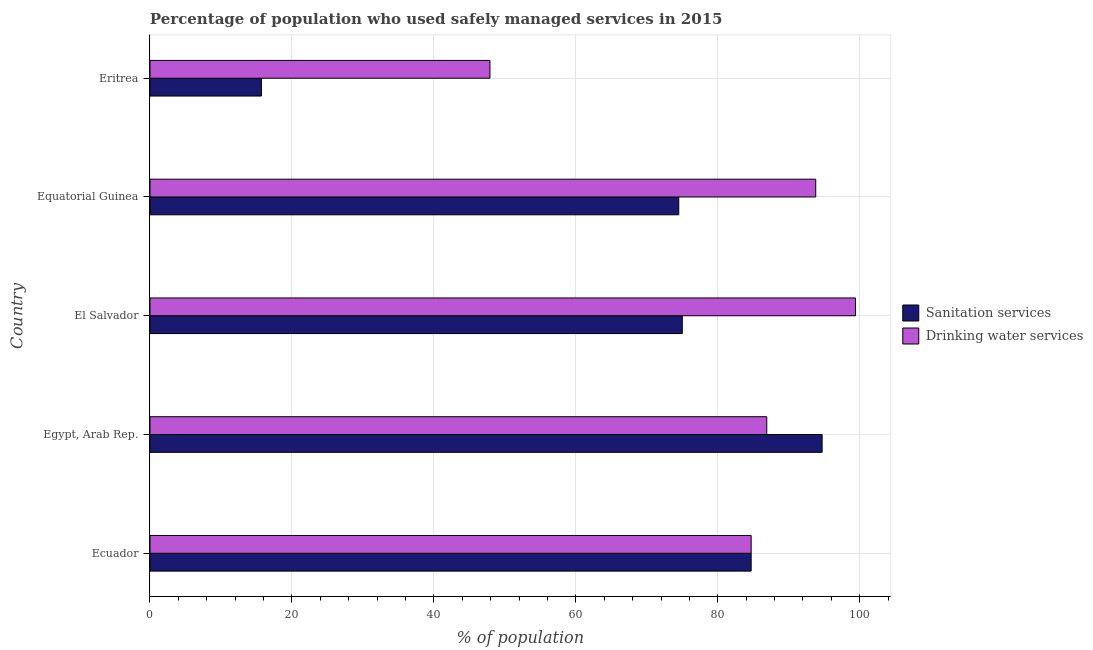How many different coloured bars are there?
Offer a very short reply. 2. How many bars are there on the 5th tick from the top?
Provide a succinct answer. 2. How many bars are there on the 3rd tick from the bottom?
Offer a very short reply. 2. What is the label of the 2nd group of bars from the top?
Provide a short and direct response. Equatorial Guinea. What is the percentage of population who used sanitation services in Ecuador?
Offer a terse response. 84.7. Across all countries, what is the maximum percentage of population who used sanitation services?
Give a very brief answer. 94.7. Across all countries, what is the minimum percentage of population who used drinking water services?
Your answer should be very brief. 47.9. In which country was the percentage of population who used sanitation services maximum?
Provide a short and direct response. Egypt, Arab Rep. In which country was the percentage of population who used sanitation services minimum?
Your response must be concise. Eritrea. What is the total percentage of population who used sanitation services in the graph?
Give a very brief answer. 344.6. What is the difference between the percentage of population who used drinking water services in Equatorial Guinea and that in Eritrea?
Your response must be concise. 45.9. What is the difference between the percentage of population who used drinking water services in Ecuador and the percentage of population who used sanitation services in Eritrea?
Your answer should be very brief. 69. What is the average percentage of population who used drinking water services per country?
Provide a short and direct response. 82.54. What is the difference between the percentage of population who used sanitation services and percentage of population who used drinking water services in Ecuador?
Offer a very short reply. 0. What is the ratio of the percentage of population who used drinking water services in Egypt, Arab Rep. to that in Eritrea?
Keep it short and to the point. 1.81. What is the difference between the highest and the second highest percentage of population who used sanitation services?
Your response must be concise. 10. What is the difference between the highest and the lowest percentage of population who used drinking water services?
Offer a terse response. 51.5. What does the 2nd bar from the top in Ecuador represents?
Give a very brief answer. Sanitation services. What does the 2nd bar from the bottom in Eritrea represents?
Your answer should be very brief. Drinking water services. How many bars are there?
Provide a short and direct response. 10. How many countries are there in the graph?
Offer a terse response. 5. What is the difference between two consecutive major ticks on the X-axis?
Your answer should be compact. 20. Are the values on the major ticks of X-axis written in scientific E-notation?
Ensure brevity in your answer.  No. Does the graph contain any zero values?
Your response must be concise. No. Where does the legend appear in the graph?
Provide a short and direct response. Center right. How many legend labels are there?
Offer a very short reply. 2. What is the title of the graph?
Provide a succinct answer. Percentage of population who used safely managed services in 2015. What is the label or title of the X-axis?
Offer a terse response. % of population. What is the % of population of Sanitation services in Ecuador?
Offer a very short reply. 84.7. What is the % of population of Drinking water services in Ecuador?
Offer a very short reply. 84.7. What is the % of population in Sanitation services in Egypt, Arab Rep.?
Your answer should be compact. 94.7. What is the % of population in Drinking water services in Egypt, Arab Rep.?
Offer a terse response. 86.9. What is the % of population of Drinking water services in El Salvador?
Offer a very short reply. 99.4. What is the % of population in Sanitation services in Equatorial Guinea?
Ensure brevity in your answer.  74.5. What is the % of population of Drinking water services in Equatorial Guinea?
Keep it short and to the point. 93.8. What is the % of population of Sanitation services in Eritrea?
Provide a short and direct response. 15.7. What is the % of population in Drinking water services in Eritrea?
Your response must be concise. 47.9. Across all countries, what is the maximum % of population of Sanitation services?
Provide a short and direct response. 94.7. Across all countries, what is the maximum % of population in Drinking water services?
Keep it short and to the point. 99.4. Across all countries, what is the minimum % of population of Drinking water services?
Keep it short and to the point. 47.9. What is the total % of population of Sanitation services in the graph?
Make the answer very short. 344.6. What is the total % of population in Drinking water services in the graph?
Offer a terse response. 412.7. What is the difference between the % of population of Sanitation services in Ecuador and that in Egypt, Arab Rep.?
Your answer should be compact. -10. What is the difference between the % of population of Drinking water services in Ecuador and that in Egypt, Arab Rep.?
Give a very brief answer. -2.2. What is the difference between the % of population of Drinking water services in Ecuador and that in El Salvador?
Ensure brevity in your answer.  -14.7. What is the difference between the % of population in Sanitation services in Ecuador and that in Eritrea?
Your answer should be compact. 69. What is the difference between the % of population in Drinking water services in Ecuador and that in Eritrea?
Offer a terse response. 36.8. What is the difference between the % of population of Drinking water services in Egypt, Arab Rep. and that in El Salvador?
Your response must be concise. -12.5. What is the difference between the % of population in Sanitation services in Egypt, Arab Rep. and that in Equatorial Guinea?
Your answer should be compact. 20.2. What is the difference between the % of population in Drinking water services in Egypt, Arab Rep. and that in Equatorial Guinea?
Your response must be concise. -6.9. What is the difference between the % of population in Sanitation services in Egypt, Arab Rep. and that in Eritrea?
Your answer should be very brief. 79. What is the difference between the % of population in Sanitation services in El Salvador and that in Eritrea?
Provide a short and direct response. 59.3. What is the difference between the % of population of Drinking water services in El Salvador and that in Eritrea?
Provide a succinct answer. 51.5. What is the difference between the % of population in Sanitation services in Equatorial Guinea and that in Eritrea?
Offer a terse response. 58.8. What is the difference between the % of population in Drinking water services in Equatorial Guinea and that in Eritrea?
Make the answer very short. 45.9. What is the difference between the % of population of Sanitation services in Ecuador and the % of population of Drinking water services in Egypt, Arab Rep.?
Your response must be concise. -2.2. What is the difference between the % of population of Sanitation services in Ecuador and the % of population of Drinking water services in El Salvador?
Offer a very short reply. -14.7. What is the difference between the % of population in Sanitation services in Ecuador and the % of population in Drinking water services in Equatorial Guinea?
Your response must be concise. -9.1. What is the difference between the % of population of Sanitation services in Ecuador and the % of population of Drinking water services in Eritrea?
Provide a succinct answer. 36.8. What is the difference between the % of population in Sanitation services in Egypt, Arab Rep. and the % of population in Drinking water services in El Salvador?
Offer a very short reply. -4.7. What is the difference between the % of population in Sanitation services in Egypt, Arab Rep. and the % of population in Drinking water services in Equatorial Guinea?
Your answer should be compact. 0.9. What is the difference between the % of population of Sanitation services in Egypt, Arab Rep. and the % of population of Drinking water services in Eritrea?
Your response must be concise. 46.8. What is the difference between the % of population of Sanitation services in El Salvador and the % of population of Drinking water services in Equatorial Guinea?
Your response must be concise. -18.8. What is the difference between the % of population in Sanitation services in El Salvador and the % of population in Drinking water services in Eritrea?
Your answer should be compact. 27.1. What is the difference between the % of population in Sanitation services in Equatorial Guinea and the % of population in Drinking water services in Eritrea?
Provide a short and direct response. 26.6. What is the average % of population of Sanitation services per country?
Your answer should be compact. 68.92. What is the average % of population of Drinking water services per country?
Make the answer very short. 82.54. What is the difference between the % of population of Sanitation services and % of population of Drinking water services in Ecuador?
Give a very brief answer. 0. What is the difference between the % of population of Sanitation services and % of population of Drinking water services in Egypt, Arab Rep.?
Provide a succinct answer. 7.8. What is the difference between the % of population of Sanitation services and % of population of Drinking water services in El Salvador?
Provide a short and direct response. -24.4. What is the difference between the % of population in Sanitation services and % of population in Drinking water services in Equatorial Guinea?
Offer a terse response. -19.3. What is the difference between the % of population of Sanitation services and % of population of Drinking water services in Eritrea?
Give a very brief answer. -32.2. What is the ratio of the % of population in Sanitation services in Ecuador to that in Egypt, Arab Rep.?
Give a very brief answer. 0.89. What is the ratio of the % of population of Drinking water services in Ecuador to that in Egypt, Arab Rep.?
Provide a short and direct response. 0.97. What is the ratio of the % of population in Sanitation services in Ecuador to that in El Salvador?
Ensure brevity in your answer.  1.13. What is the ratio of the % of population in Drinking water services in Ecuador to that in El Salvador?
Provide a succinct answer. 0.85. What is the ratio of the % of population in Sanitation services in Ecuador to that in Equatorial Guinea?
Ensure brevity in your answer.  1.14. What is the ratio of the % of population in Drinking water services in Ecuador to that in Equatorial Guinea?
Give a very brief answer. 0.9. What is the ratio of the % of population in Sanitation services in Ecuador to that in Eritrea?
Your answer should be compact. 5.39. What is the ratio of the % of population in Drinking water services in Ecuador to that in Eritrea?
Make the answer very short. 1.77. What is the ratio of the % of population of Sanitation services in Egypt, Arab Rep. to that in El Salvador?
Give a very brief answer. 1.26. What is the ratio of the % of population of Drinking water services in Egypt, Arab Rep. to that in El Salvador?
Your response must be concise. 0.87. What is the ratio of the % of population of Sanitation services in Egypt, Arab Rep. to that in Equatorial Guinea?
Provide a succinct answer. 1.27. What is the ratio of the % of population in Drinking water services in Egypt, Arab Rep. to that in Equatorial Guinea?
Give a very brief answer. 0.93. What is the ratio of the % of population of Sanitation services in Egypt, Arab Rep. to that in Eritrea?
Provide a short and direct response. 6.03. What is the ratio of the % of population of Drinking water services in Egypt, Arab Rep. to that in Eritrea?
Your response must be concise. 1.81. What is the ratio of the % of population in Sanitation services in El Salvador to that in Equatorial Guinea?
Offer a very short reply. 1.01. What is the ratio of the % of population of Drinking water services in El Salvador to that in Equatorial Guinea?
Ensure brevity in your answer.  1.06. What is the ratio of the % of population in Sanitation services in El Salvador to that in Eritrea?
Keep it short and to the point. 4.78. What is the ratio of the % of population in Drinking water services in El Salvador to that in Eritrea?
Offer a very short reply. 2.08. What is the ratio of the % of population of Sanitation services in Equatorial Guinea to that in Eritrea?
Keep it short and to the point. 4.75. What is the ratio of the % of population in Drinking water services in Equatorial Guinea to that in Eritrea?
Offer a terse response. 1.96. What is the difference between the highest and the second highest % of population of Sanitation services?
Provide a short and direct response. 10. What is the difference between the highest and the lowest % of population of Sanitation services?
Provide a succinct answer. 79. What is the difference between the highest and the lowest % of population in Drinking water services?
Keep it short and to the point. 51.5. 